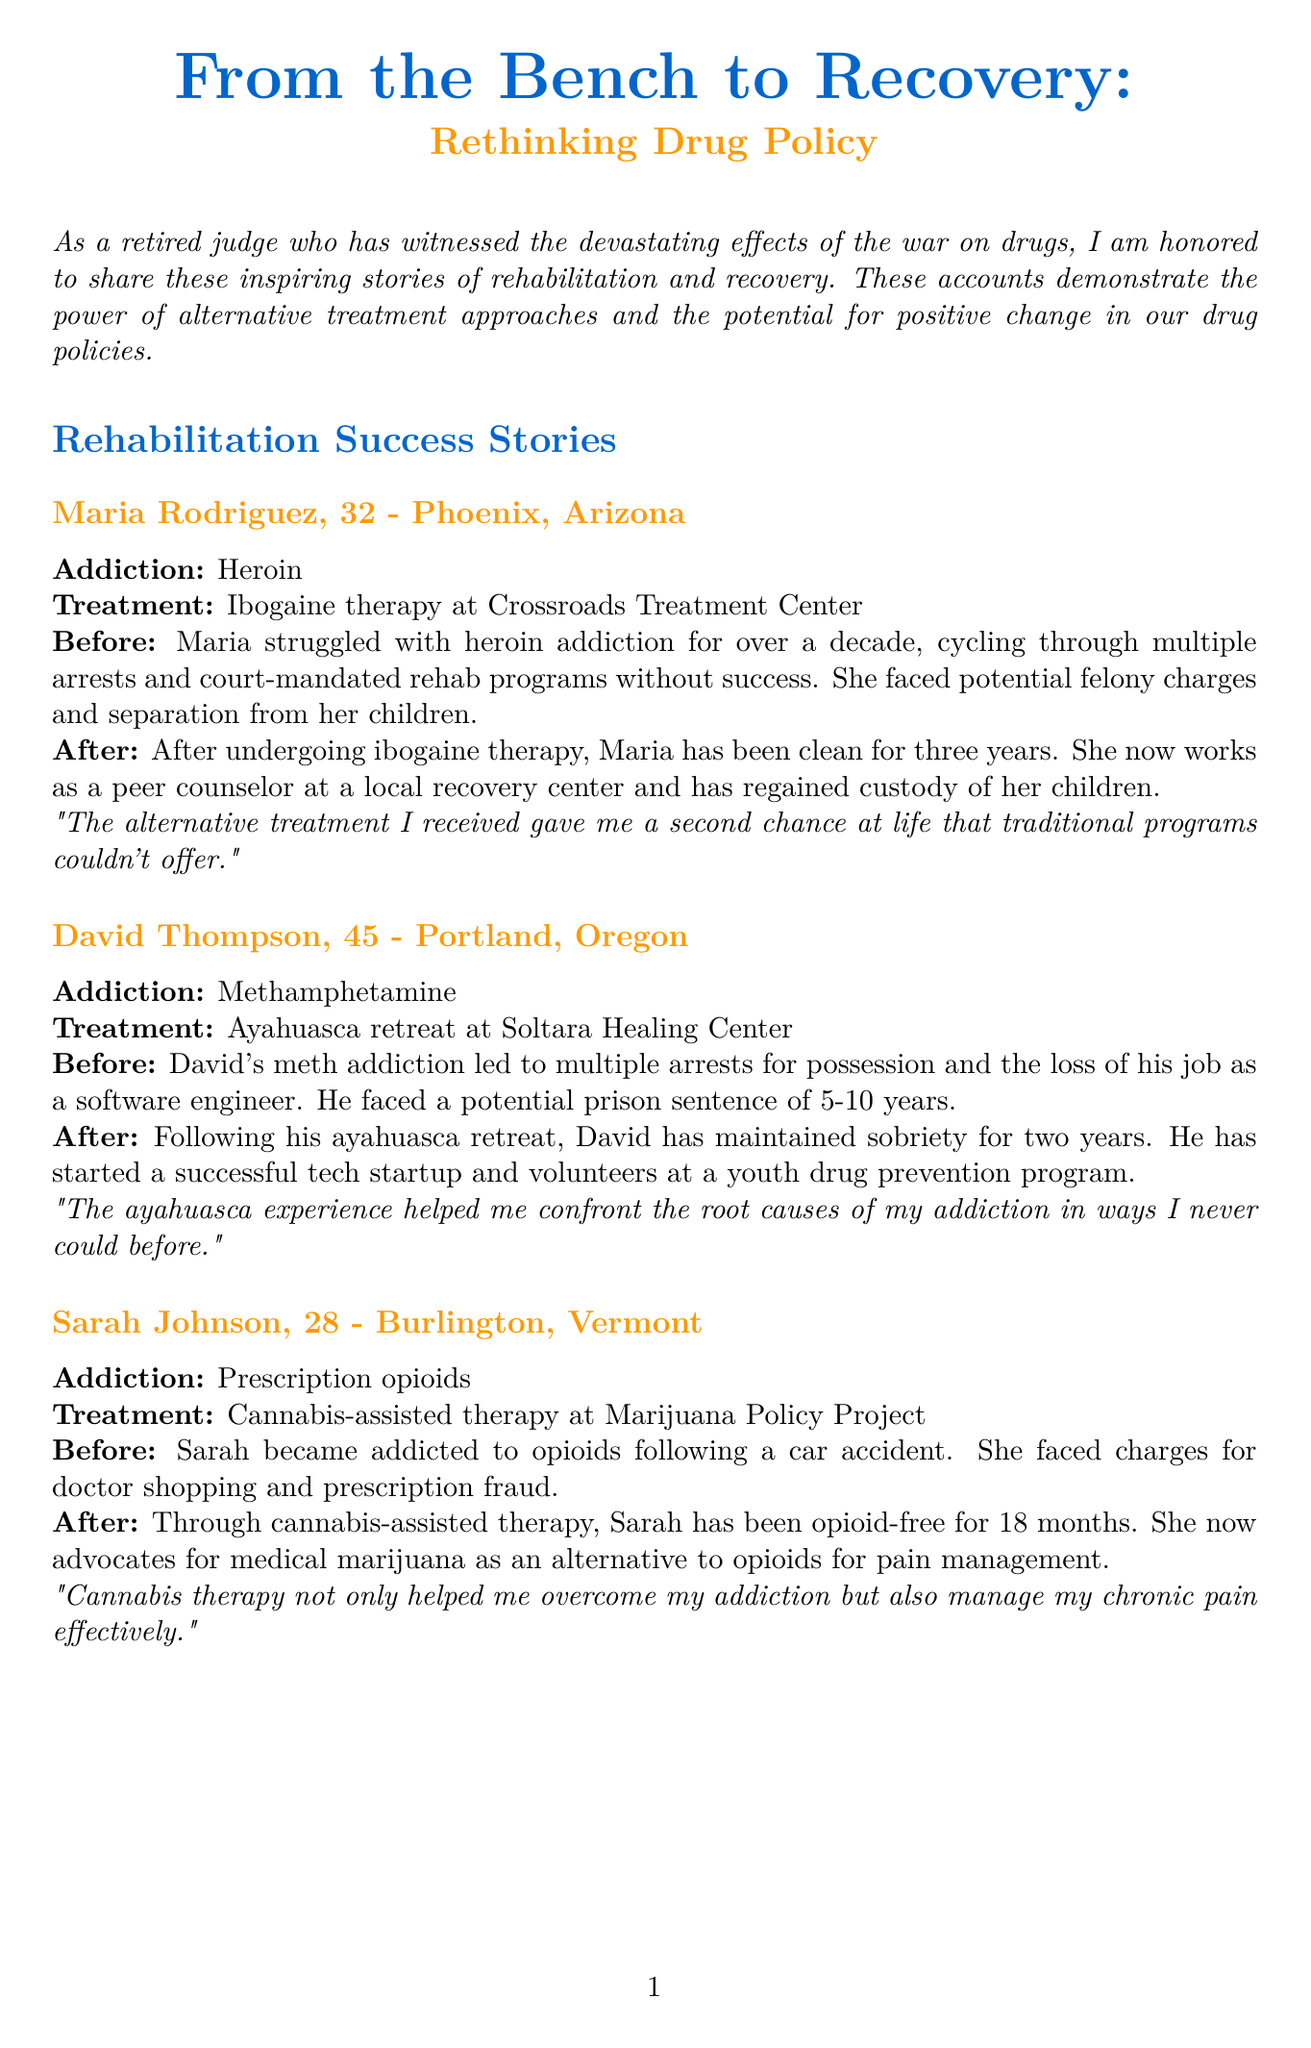What was Maria Rodriguez's addiction? Maria struggled with heroin addiction, which is detailed in her story.
Answer: Heroin How long has David Thompson maintained sobriety? The document states that David has maintained sobriety for two years since his treatment.
Answer: Two years What treatment did Sarah Johnson undergo? The treatment Sarah received is specified explicitly in her section, which is cannabis-assisted therapy.
Answer: Cannabis-assisted therapy What is the recidivism rate for drug offenders completing alternative treatment programs? The document provides this statistic directly, which is 17%.
Answer: 17% What quote did Dr. Gabriela Monteiro provide about alternative treatment programs? The quote reflects her view on alternative treatment, emphasizing healing rather than punishment.
Answer: "Alternative treatment programs offer a more humane and effective approach to addressing drug addiction." How many children did Maria Rodriguez regain custody of after treatment? The document mentions that Maria regained custody of her children after her treatment.
Answer: Custody of her children What is the percentage of participants who maintain employment after alternative treatment? The document includes this important statistic, which is 72%.
Answer: 72% What city is Sarah Johnson from? The document specifies her location as Burlington, Vermont.
Answer: Burlington, Vermont 